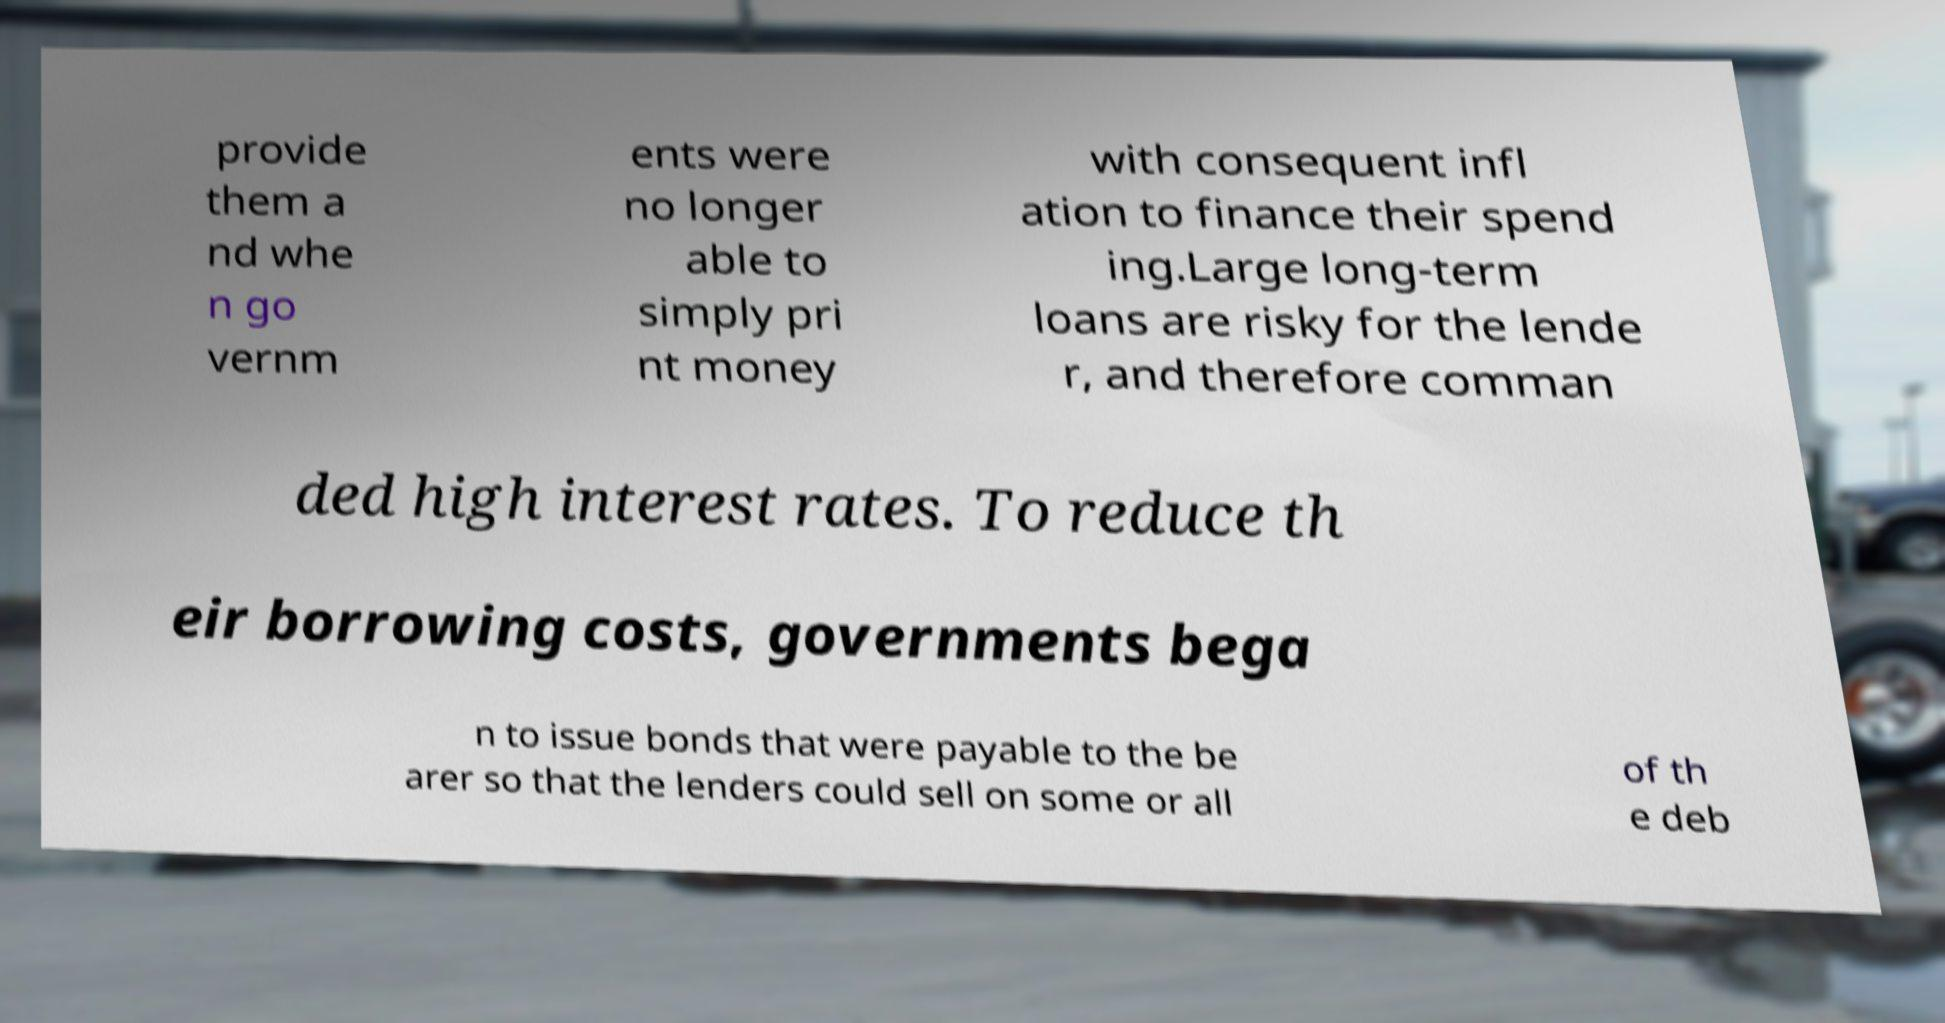For documentation purposes, I need the text within this image transcribed. Could you provide that? provide them a nd whe n go vernm ents were no longer able to simply pri nt money with consequent infl ation to finance their spend ing.Large long-term loans are risky for the lende r, and therefore comman ded high interest rates. To reduce th eir borrowing costs, governments bega n to issue bonds that were payable to the be arer so that the lenders could sell on some or all of th e deb 